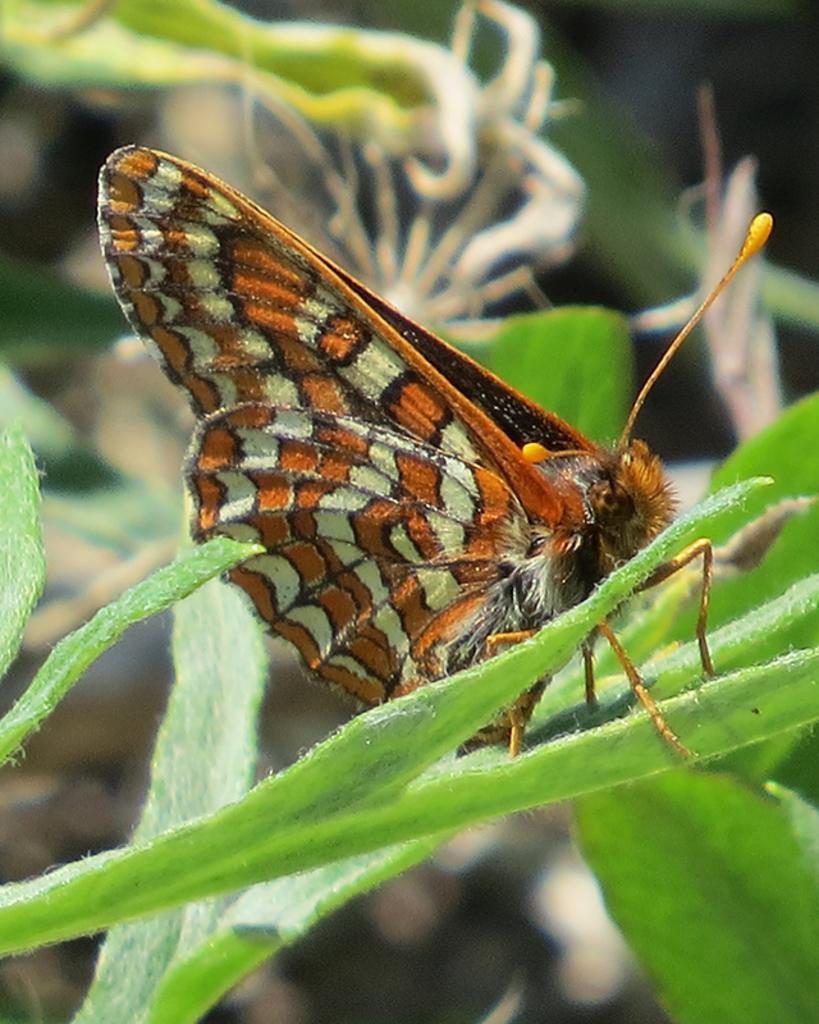In one or two sentences, can you explain what this image depicts? In this image I can see a butterfly and the butterfly is in white, brown and black color and the butterfly is on the leaf, and the leaves are in green color. 